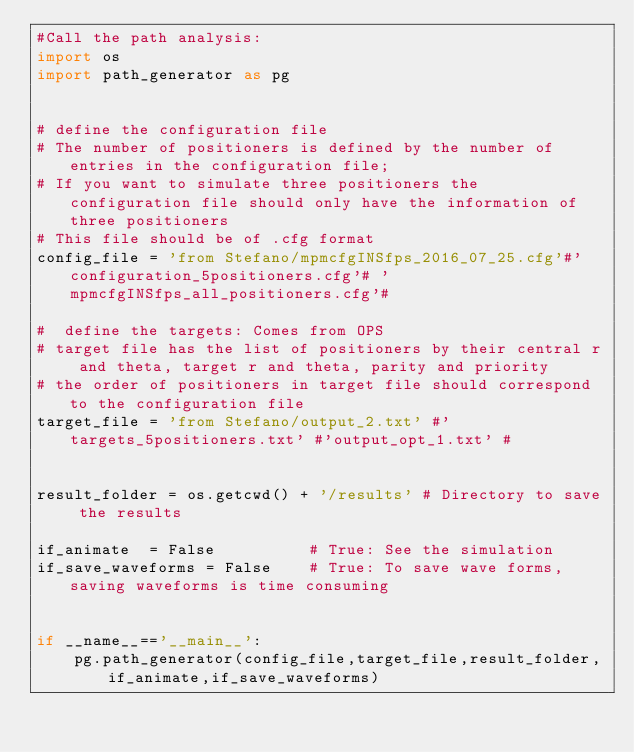Convert code to text. <code><loc_0><loc_0><loc_500><loc_500><_Python_>#Call the path analysis:
import os
import path_generator as pg


# define the configuration file
# The number of positioners is defined by the number of entries in the configuration file;
# If you want to simulate three positioners the configuration file should only have the information of three positioners
# This file should be of .cfg format
config_file = 'from Stefano/mpmcfgINSfps_2016_07_25.cfg'#'configuration_5positioners.cfg'# 'mpmcfgINSfps_all_positioners.cfg'#

#  define the targets: Comes from OPS
# target file has the list of positioners by their central r and theta, target r and theta, parity and priority
# the order of positioners in target file should correspond to the configuration file
target_file = 'from Stefano/output_2.txt' #'targets_5positioners.txt' #'output_opt_1.txt' #


result_folder = os.getcwd() + '/results' # Directory to save the results

if_animate  = False          # True: See the simulation
if_save_waveforms = False    # True: To save wave forms, saving waveforms is time consuming


if __name__=='__main__':
    pg.path_generator(config_file,target_file,result_folder,if_animate,if_save_waveforms)

</code> 